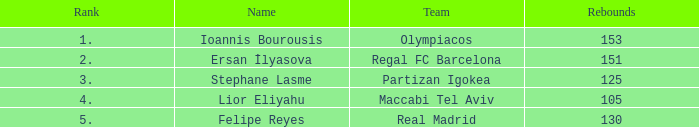What rank is Partizan Igokea that has less than 130 rebounds? 3.0. Write the full table. {'header': ['Rank', 'Name', 'Team', 'Rebounds'], 'rows': [['1.', 'Ioannis Bourousis', 'Olympiacos', '153'], ['2.', 'Ersan İlyasova', 'Regal FC Barcelona', '151'], ['3.', 'Stephane Lasme', 'Partizan Igokea', '125'], ['4.', 'Lior Eliyahu', 'Maccabi Tel Aviv', '105'], ['5.', 'Felipe Reyes', 'Real Madrid', '130']]} 